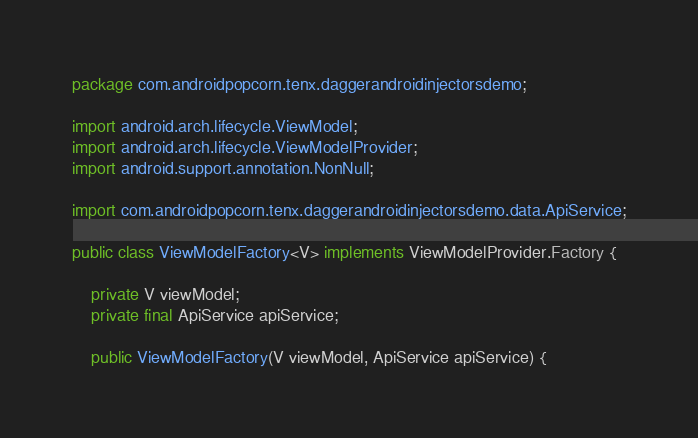Convert code to text. <code><loc_0><loc_0><loc_500><loc_500><_Java_>package com.androidpopcorn.tenx.daggerandroidinjectorsdemo;

import android.arch.lifecycle.ViewModel;
import android.arch.lifecycle.ViewModelProvider;
import android.support.annotation.NonNull;

import com.androidpopcorn.tenx.daggerandroidinjectorsdemo.data.ApiService;

public class ViewModelFactory<V> implements ViewModelProvider.Factory {

    private V viewModel;
    private final ApiService apiService;

    public ViewModelFactory(V viewModel, ApiService apiService) {</code> 